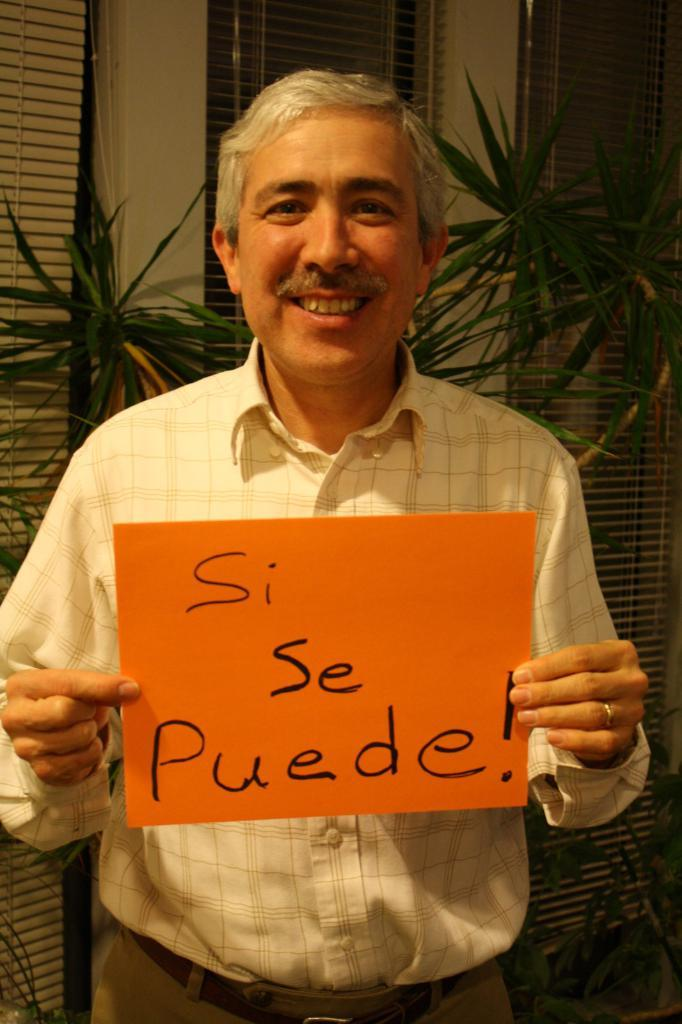Who is the main subject in the image? There is a man in the middle of the image. What is the man holding in the image? The man is holding a placard. What can be seen in the background of the image? There are plants and windows in the background of the image. What type of flesh can be seen on the man's face in the image? There is no mention of the man's face or any flesh in the provided facts, so we cannot answer this question. 